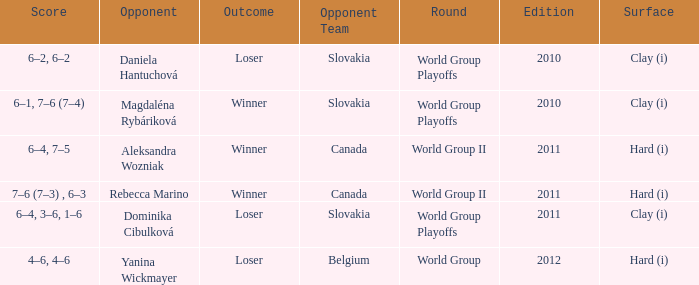What was the score when the opposing team was from Belgium? 4–6, 4–6. 